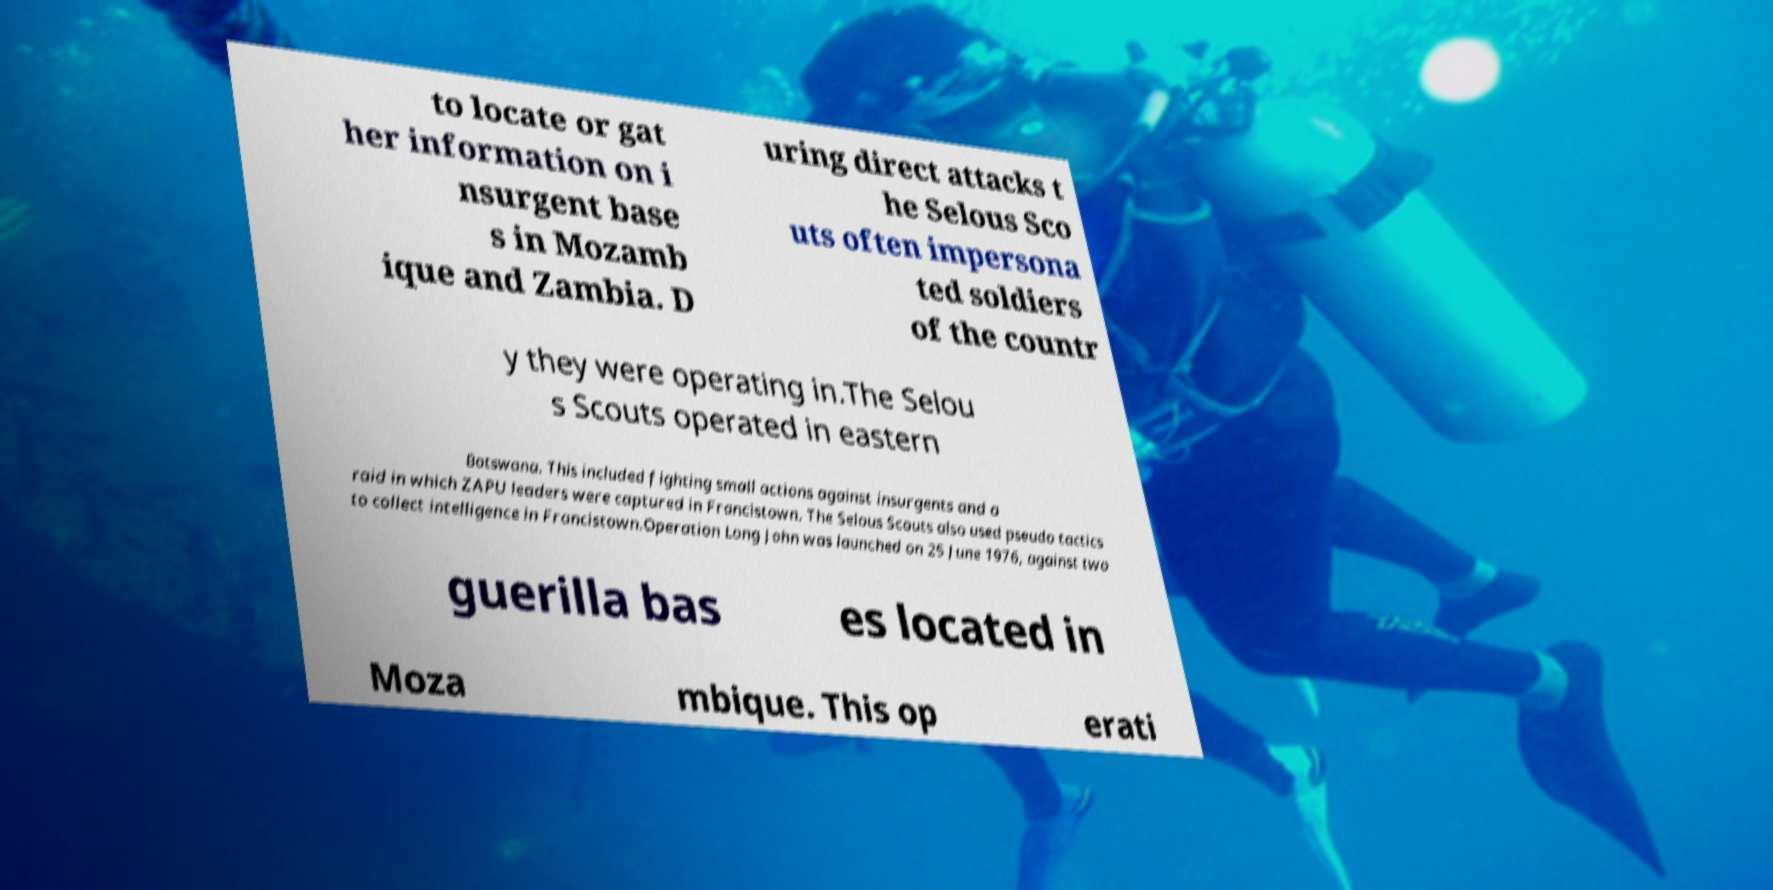Please read and relay the text visible in this image. What does it say? to locate or gat her information on i nsurgent base s in Mozamb ique and Zambia. D uring direct attacks t he Selous Sco uts often impersona ted soldiers of the countr y they were operating in.The Selou s Scouts operated in eastern Botswana. This included fighting small actions against insurgents and a raid in which ZAPU leaders were captured in Francistown. The Selous Scouts also used pseudo tactics to collect intelligence in Francistown.Operation Long John was launched on 25 June 1976, against two guerilla bas es located in Moza mbique. This op erati 